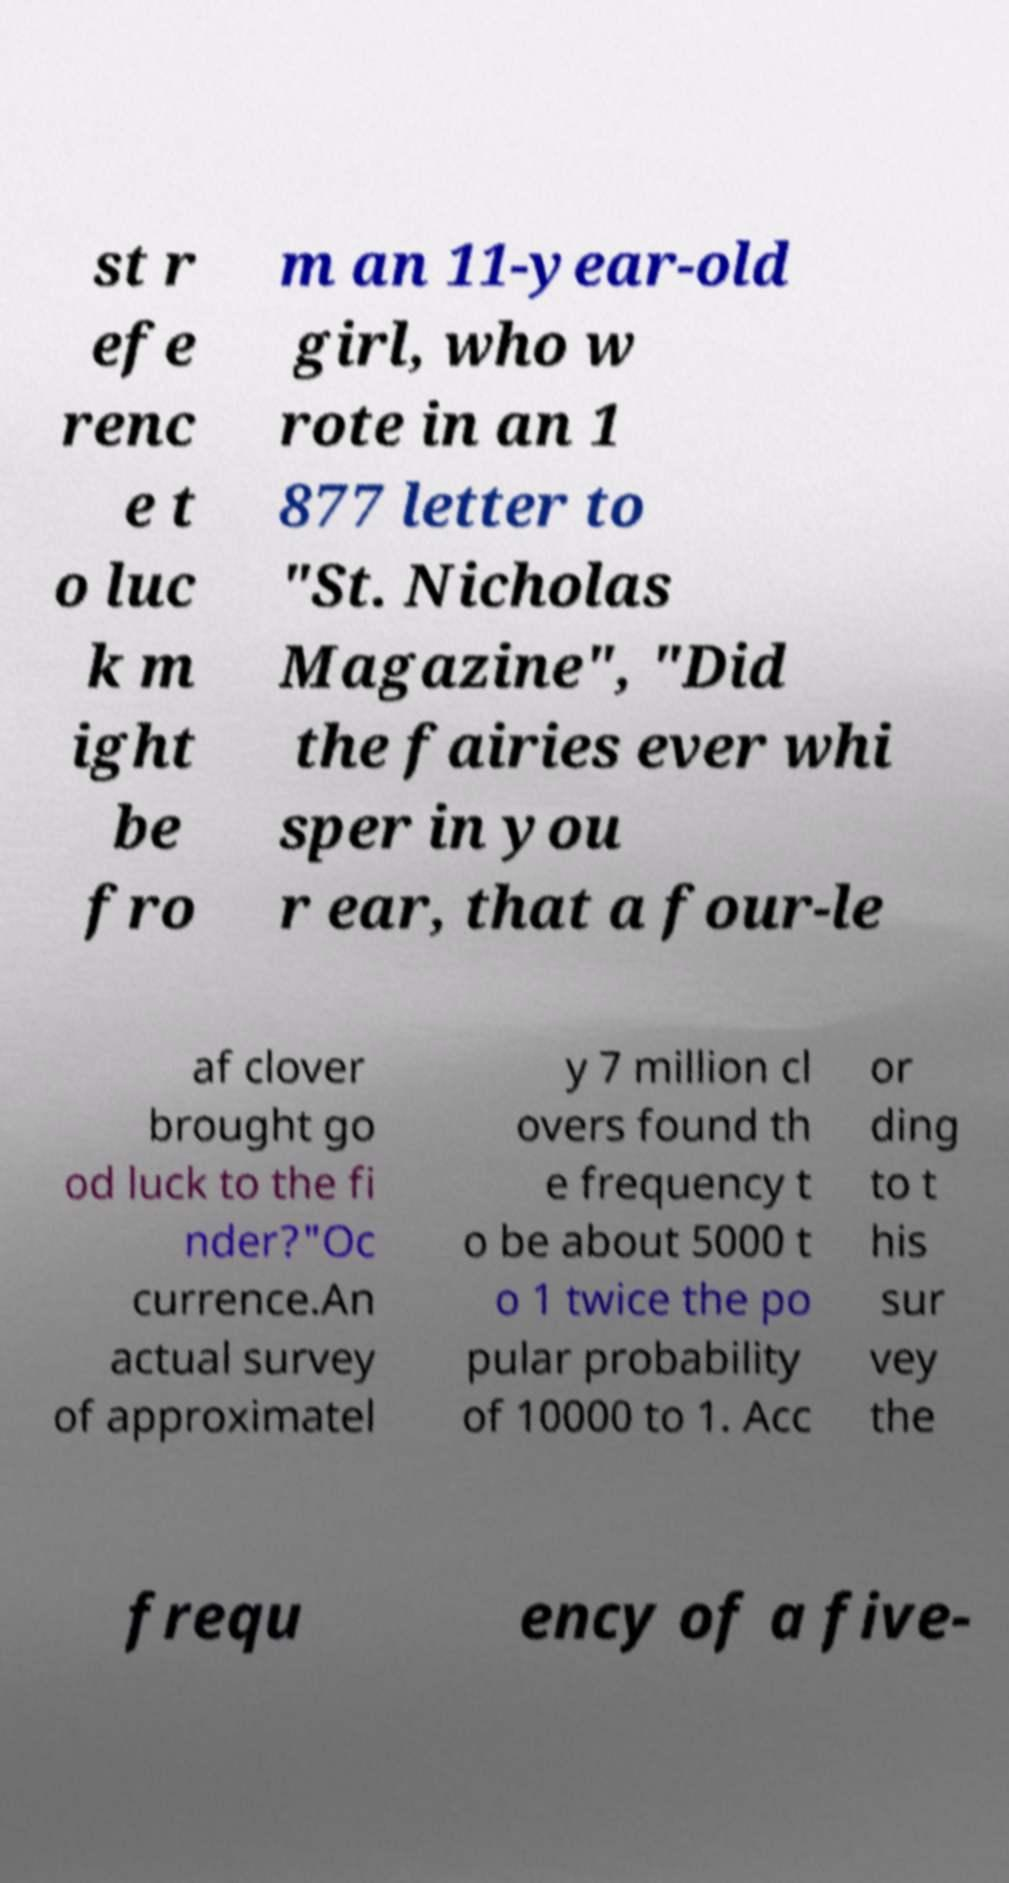I need the written content from this picture converted into text. Can you do that? st r efe renc e t o luc k m ight be fro m an 11-year-old girl, who w rote in an 1 877 letter to "St. Nicholas Magazine", "Did the fairies ever whi sper in you r ear, that a four-le af clover brought go od luck to the fi nder?"Oc currence.An actual survey of approximatel y 7 million cl overs found th e frequency t o be about 5000 t o 1 twice the po pular probability of 10000 to 1. Acc or ding to t his sur vey the frequ ency of a five- 